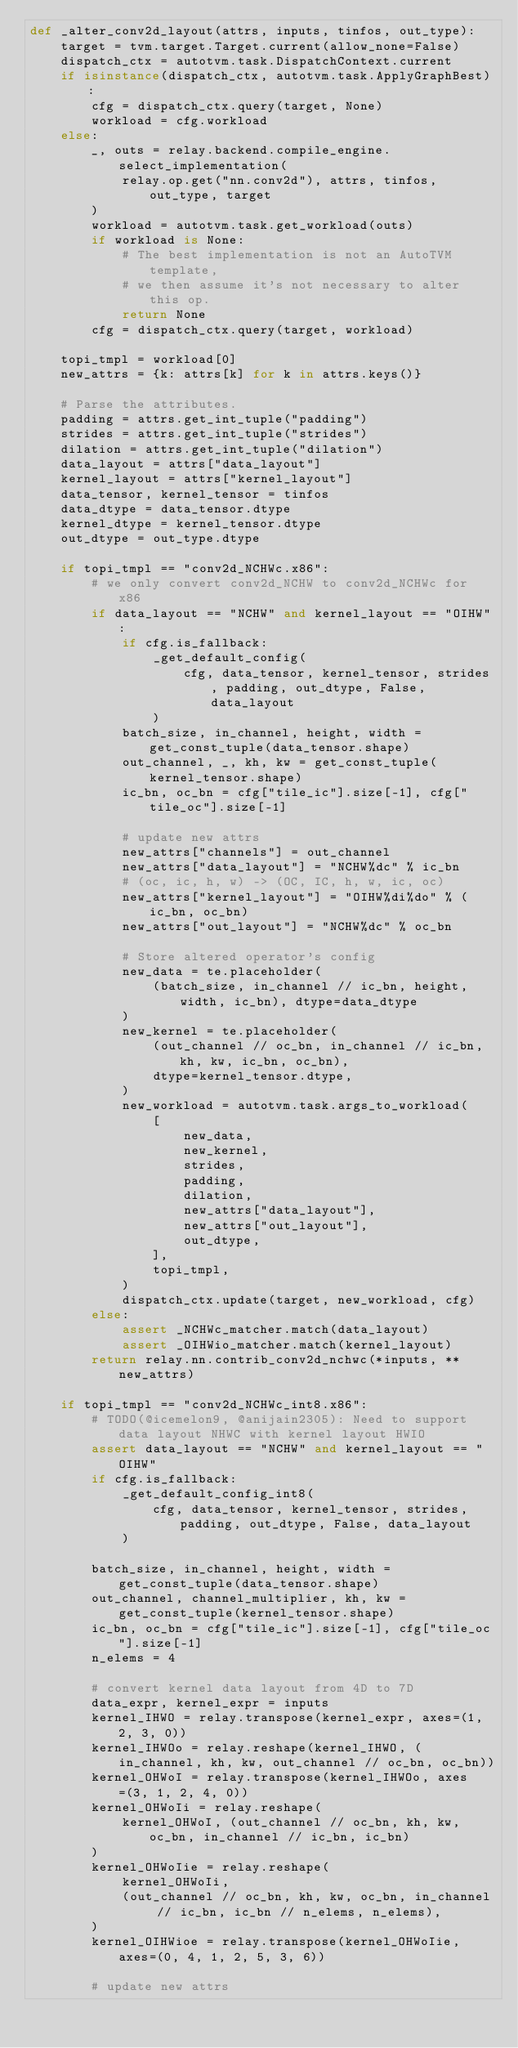Convert code to text. <code><loc_0><loc_0><loc_500><loc_500><_Python_>def _alter_conv2d_layout(attrs, inputs, tinfos, out_type):
    target = tvm.target.Target.current(allow_none=False)
    dispatch_ctx = autotvm.task.DispatchContext.current
    if isinstance(dispatch_ctx, autotvm.task.ApplyGraphBest):
        cfg = dispatch_ctx.query(target, None)
        workload = cfg.workload
    else:
        _, outs = relay.backend.compile_engine.select_implementation(
            relay.op.get("nn.conv2d"), attrs, tinfos, out_type, target
        )
        workload = autotvm.task.get_workload(outs)
        if workload is None:
            # The best implementation is not an AutoTVM template,
            # we then assume it's not necessary to alter this op.
            return None
        cfg = dispatch_ctx.query(target, workload)

    topi_tmpl = workload[0]
    new_attrs = {k: attrs[k] for k in attrs.keys()}

    # Parse the attributes.
    padding = attrs.get_int_tuple("padding")
    strides = attrs.get_int_tuple("strides")
    dilation = attrs.get_int_tuple("dilation")
    data_layout = attrs["data_layout"]
    kernel_layout = attrs["kernel_layout"]
    data_tensor, kernel_tensor = tinfos
    data_dtype = data_tensor.dtype
    kernel_dtype = kernel_tensor.dtype
    out_dtype = out_type.dtype

    if topi_tmpl == "conv2d_NCHWc.x86":
        # we only convert conv2d_NCHW to conv2d_NCHWc for x86
        if data_layout == "NCHW" and kernel_layout == "OIHW":
            if cfg.is_fallback:
                _get_default_config(
                    cfg, data_tensor, kernel_tensor, strides, padding, out_dtype, False, data_layout
                )
            batch_size, in_channel, height, width = get_const_tuple(data_tensor.shape)
            out_channel, _, kh, kw = get_const_tuple(kernel_tensor.shape)
            ic_bn, oc_bn = cfg["tile_ic"].size[-1], cfg["tile_oc"].size[-1]

            # update new attrs
            new_attrs["channels"] = out_channel
            new_attrs["data_layout"] = "NCHW%dc" % ic_bn
            # (oc, ic, h, w) -> (OC, IC, h, w, ic, oc)
            new_attrs["kernel_layout"] = "OIHW%di%do" % (ic_bn, oc_bn)
            new_attrs["out_layout"] = "NCHW%dc" % oc_bn

            # Store altered operator's config
            new_data = te.placeholder(
                (batch_size, in_channel // ic_bn, height, width, ic_bn), dtype=data_dtype
            )
            new_kernel = te.placeholder(
                (out_channel // oc_bn, in_channel // ic_bn, kh, kw, ic_bn, oc_bn),
                dtype=kernel_tensor.dtype,
            )
            new_workload = autotvm.task.args_to_workload(
                [
                    new_data,
                    new_kernel,
                    strides,
                    padding,
                    dilation,
                    new_attrs["data_layout"],
                    new_attrs["out_layout"],
                    out_dtype,
                ],
                topi_tmpl,
            )
            dispatch_ctx.update(target, new_workload, cfg)
        else:
            assert _NCHWc_matcher.match(data_layout)
            assert _OIHWio_matcher.match(kernel_layout)
        return relay.nn.contrib_conv2d_nchwc(*inputs, **new_attrs)

    if topi_tmpl == "conv2d_NCHWc_int8.x86":
        # TODO(@icemelon9, @anijain2305): Need to support data layout NHWC with kernel layout HWIO
        assert data_layout == "NCHW" and kernel_layout == "OIHW"
        if cfg.is_fallback:
            _get_default_config_int8(
                cfg, data_tensor, kernel_tensor, strides, padding, out_dtype, False, data_layout
            )

        batch_size, in_channel, height, width = get_const_tuple(data_tensor.shape)
        out_channel, channel_multiplier, kh, kw = get_const_tuple(kernel_tensor.shape)
        ic_bn, oc_bn = cfg["tile_ic"].size[-1], cfg["tile_oc"].size[-1]
        n_elems = 4

        # convert kernel data layout from 4D to 7D
        data_expr, kernel_expr = inputs
        kernel_IHWO = relay.transpose(kernel_expr, axes=(1, 2, 3, 0))
        kernel_IHWOo = relay.reshape(kernel_IHWO, (in_channel, kh, kw, out_channel // oc_bn, oc_bn))
        kernel_OHWoI = relay.transpose(kernel_IHWOo, axes=(3, 1, 2, 4, 0))
        kernel_OHWoIi = relay.reshape(
            kernel_OHWoI, (out_channel // oc_bn, kh, kw, oc_bn, in_channel // ic_bn, ic_bn)
        )
        kernel_OHWoIie = relay.reshape(
            kernel_OHWoIi,
            (out_channel // oc_bn, kh, kw, oc_bn, in_channel // ic_bn, ic_bn // n_elems, n_elems),
        )
        kernel_OIHWioe = relay.transpose(kernel_OHWoIie, axes=(0, 4, 1, 2, 5, 3, 6))

        # update new attrs</code> 